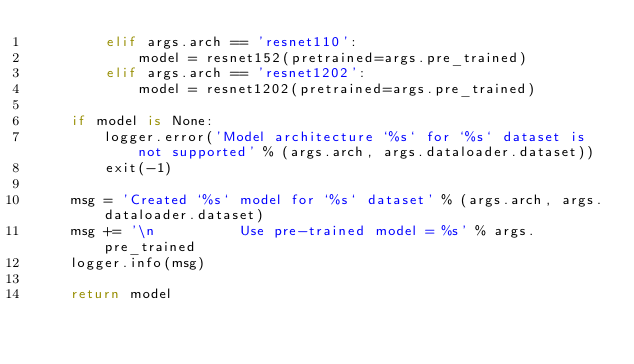Convert code to text. <code><loc_0><loc_0><loc_500><loc_500><_Python_>        elif args.arch == 'resnet110':
            model = resnet152(pretrained=args.pre_trained)
        elif args.arch == 'resnet1202':
            model = resnet1202(pretrained=args.pre_trained)

    if model is None:
        logger.error('Model architecture `%s` for `%s` dataset is not supported' % (args.arch, args.dataloader.dataset))
        exit(-1)

    msg = 'Created `%s` model for `%s` dataset' % (args.arch, args.dataloader.dataset)
    msg += '\n          Use pre-trained model = %s' % args.pre_trained
    logger.info(msg)

    return model
</code> 